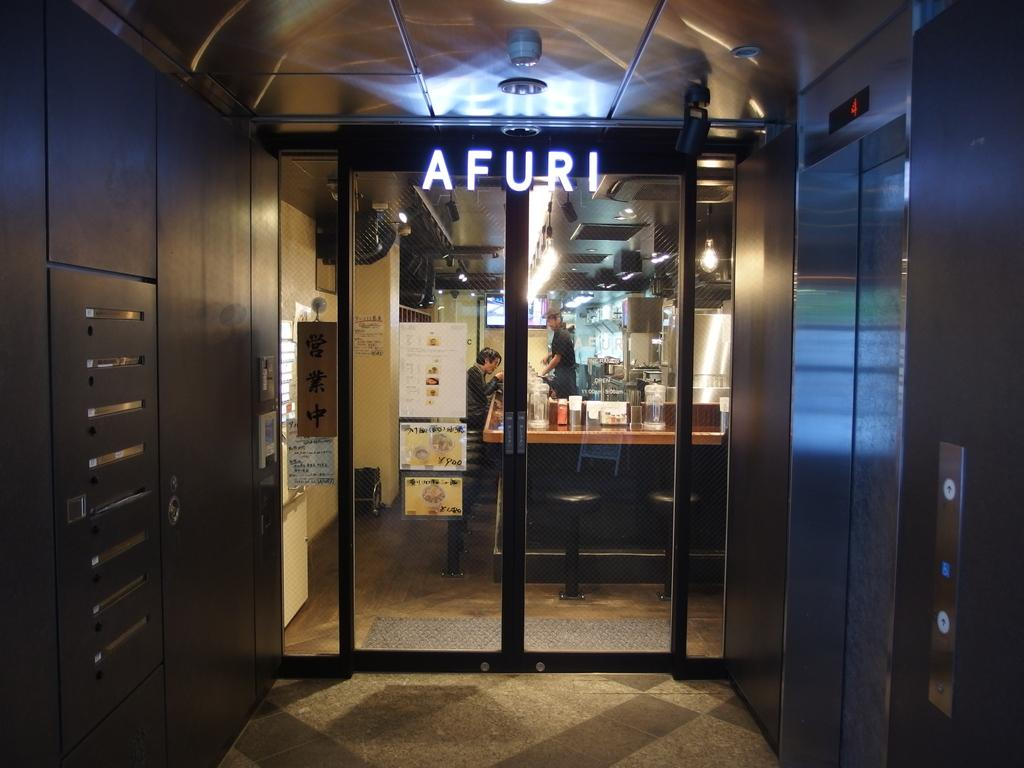<image>
Give a short and clear explanation of the subsequent image. Afuri sign in big letters on a front door. 